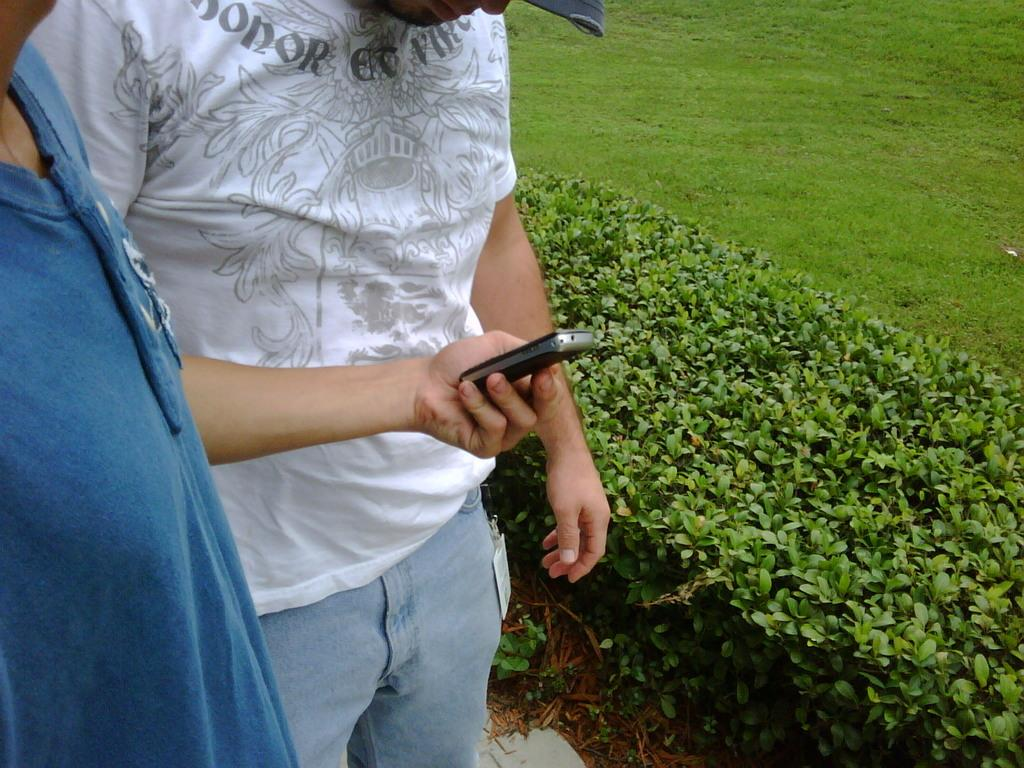What is the man in the image wearing? The man is wearing a white t-shirt and blue jeans. Who is standing beside the man in the image? There is a person beside the man, and they are wearing a blue dress. What can be seen on the right side of the image? There are bushes on the right side of the image. What type of instrument is the man playing in the image? There is no instrument present in the image, and the man is not playing any instrument. 